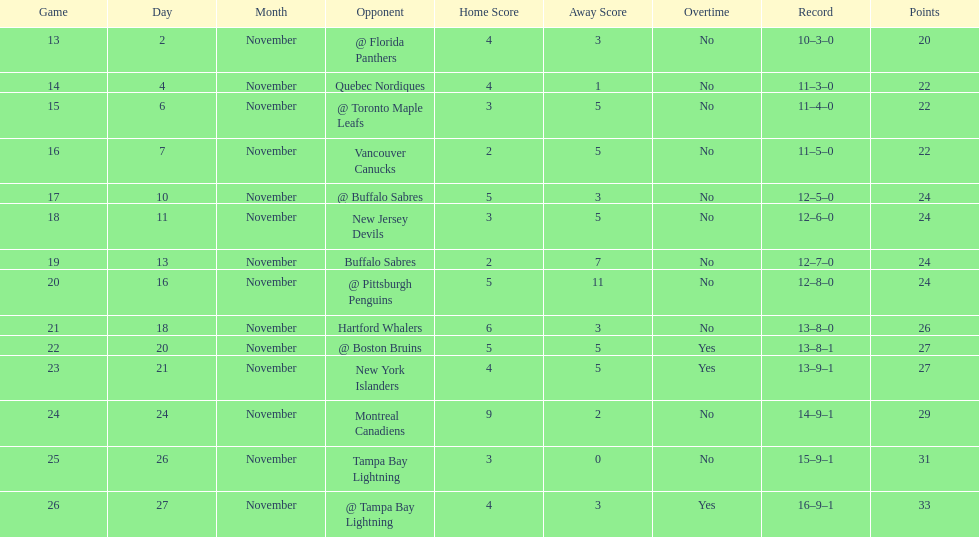Which was the only team in the atlantic division in the 1993-1994 season to acquire less points than the philadelphia flyers? Tampa Bay Lightning. 